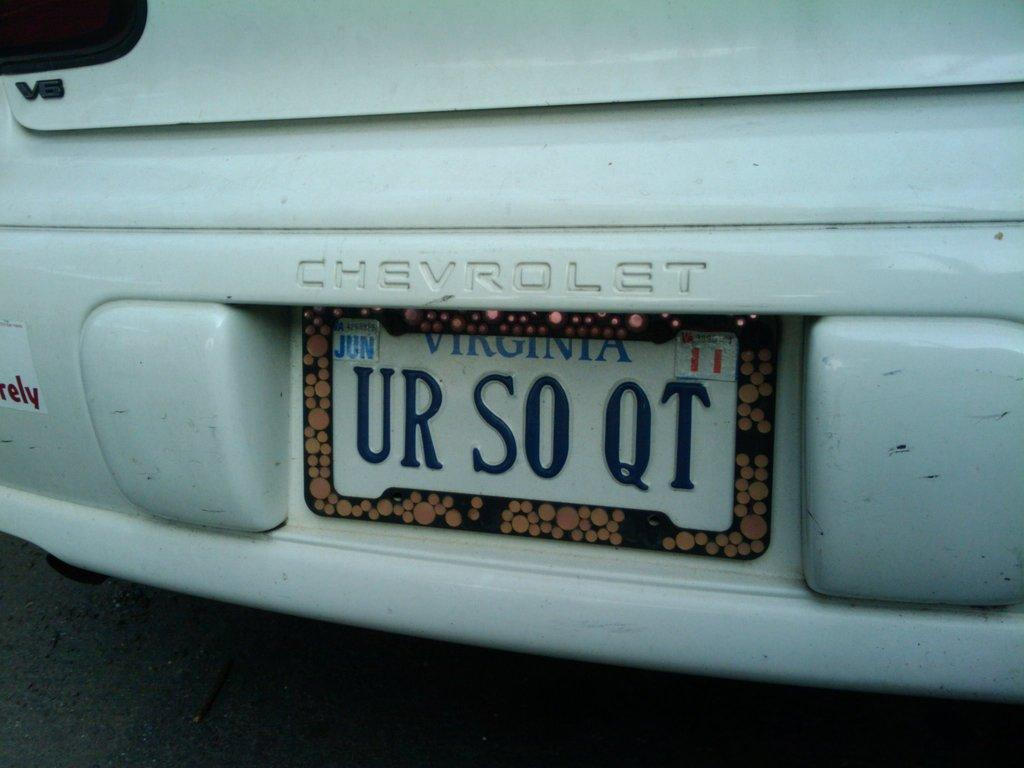<image>
Write a terse but informative summary of the picture. The car is from Virginia with license plate number UR S0 QT 